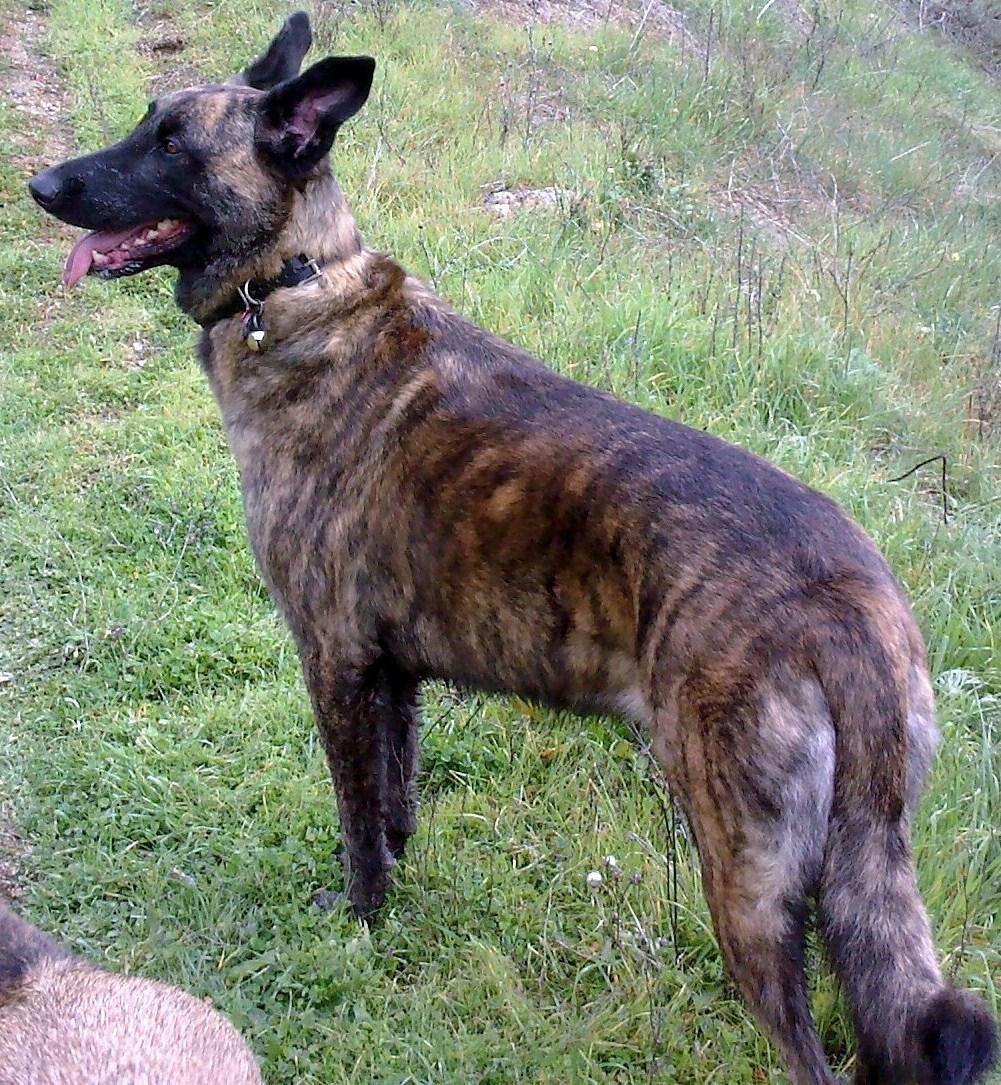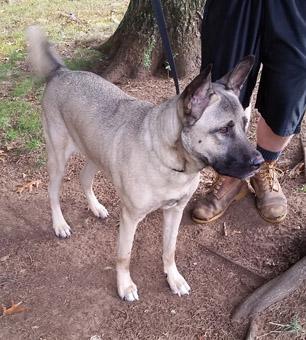The first image is the image on the left, the second image is the image on the right. Analyze the images presented: Is the assertion "There are two dogs standing in the grass." valid? Answer yes or no. Yes. The first image is the image on the left, the second image is the image on the right. Evaluate the accuracy of this statement regarding the images: "There are 2 dogs standing.". Is it true? Answer yes or no. Yes. 